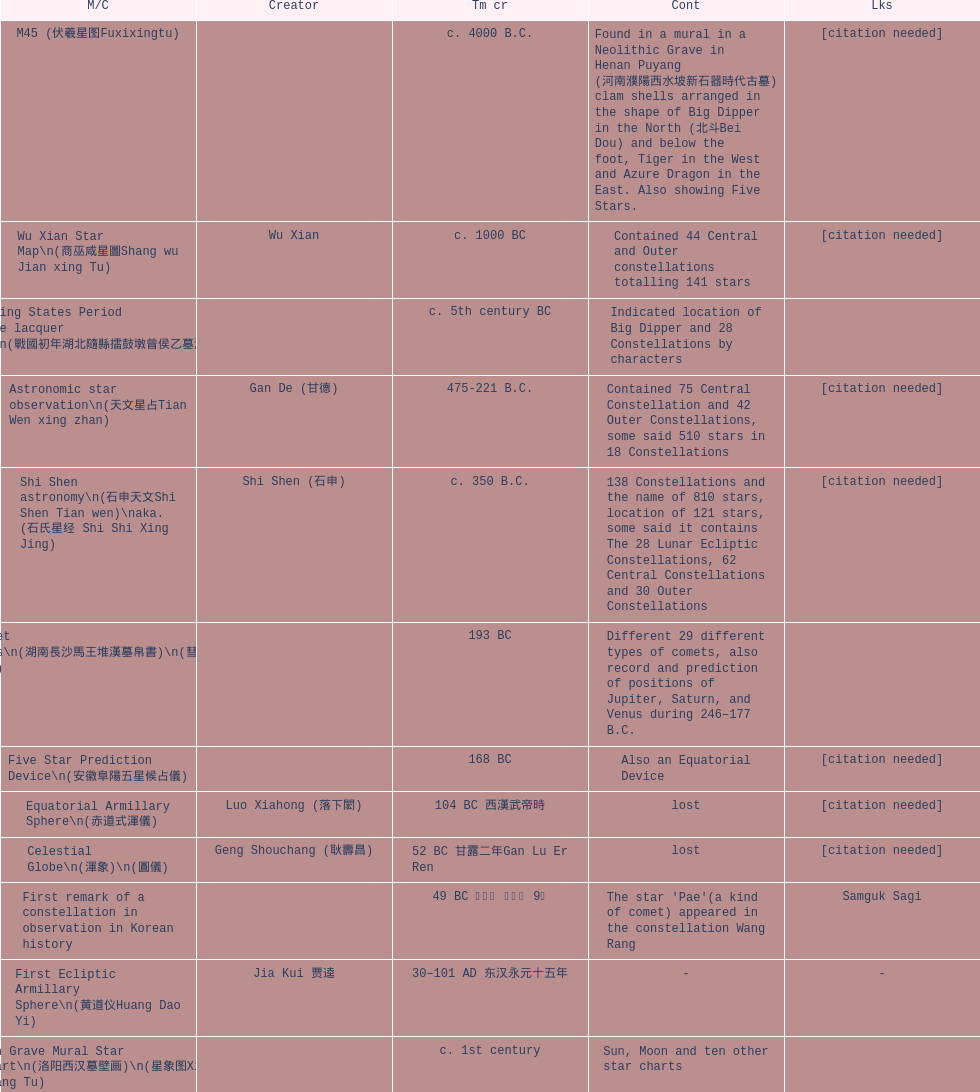When was the initial map or catalog developed? C. 4000 b.c. 